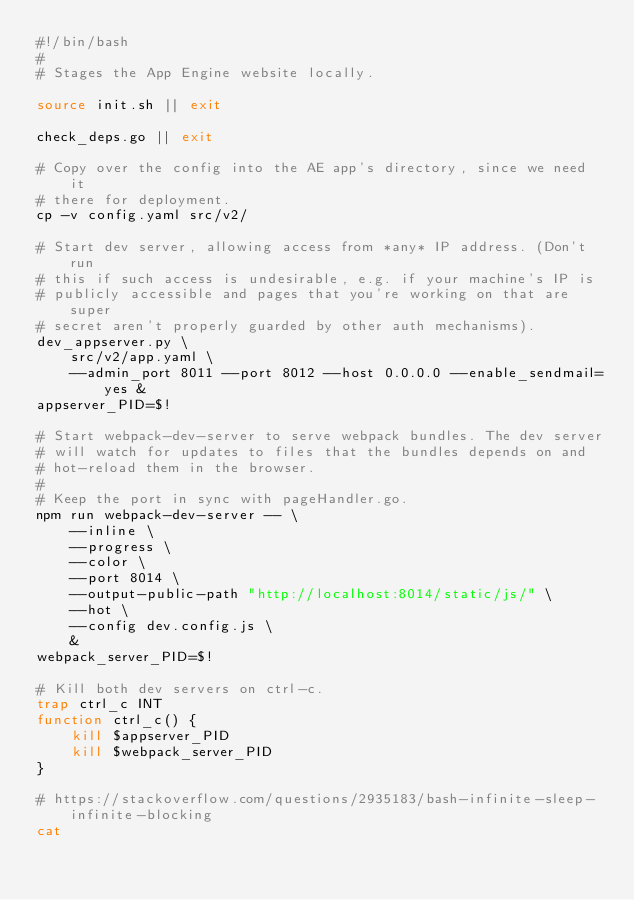Convert code to text. <code><loc_0><loc_0><loc_500><loc_500><_Bash_>#!/bin/bash
#
# Stages the App Engine website locally.

source init.sh || exit

check_deps.go || exit

# Copy over the config into the AE app's directory, since we need it
# there for deployment.
cp -v config.yaml src/v2/

# Start dev server, allowing access from *any* IP address. (Don't run
# this if such access is undesirable, e.g. if your machine's IP is
# publicly accessible and pages that you're working on that are super
# secret aren't properly guarded by other auth mechanisms).
dev_appserver.py \
	src/v2/app.yaml \
	--admin_port 8011 --port 8012 --host 0.0.0.0 --enable_sendmail=yes &
appserver_PID=$!

# Start webpack-dev-server to serve webpack bundles. The dev server
# will watch for updates to files that the bundles depends on and
# hot-reload them in the browser.
#
# Keep the port in sync with pageHandler.go.
npm run webpack-dev-server -- \
    --inline \
    --progress \
    --color \
    --port 8014 \
    --output-public-path "http://localhost:8014/static/js/" \
    --hot \
    --config dev.config.js \
    &
webpack_server_PID=$!

# Kill both dev servers on ctrl-c.
trap ctrl_c INT
function ctrl_c() {
    kill $appserver_PID
    kill $webpack_server_PID
}

# https://stackoverflow.com/questions/2935183/bash-infinite-sleep-infinite-blocking
cat
</code> 